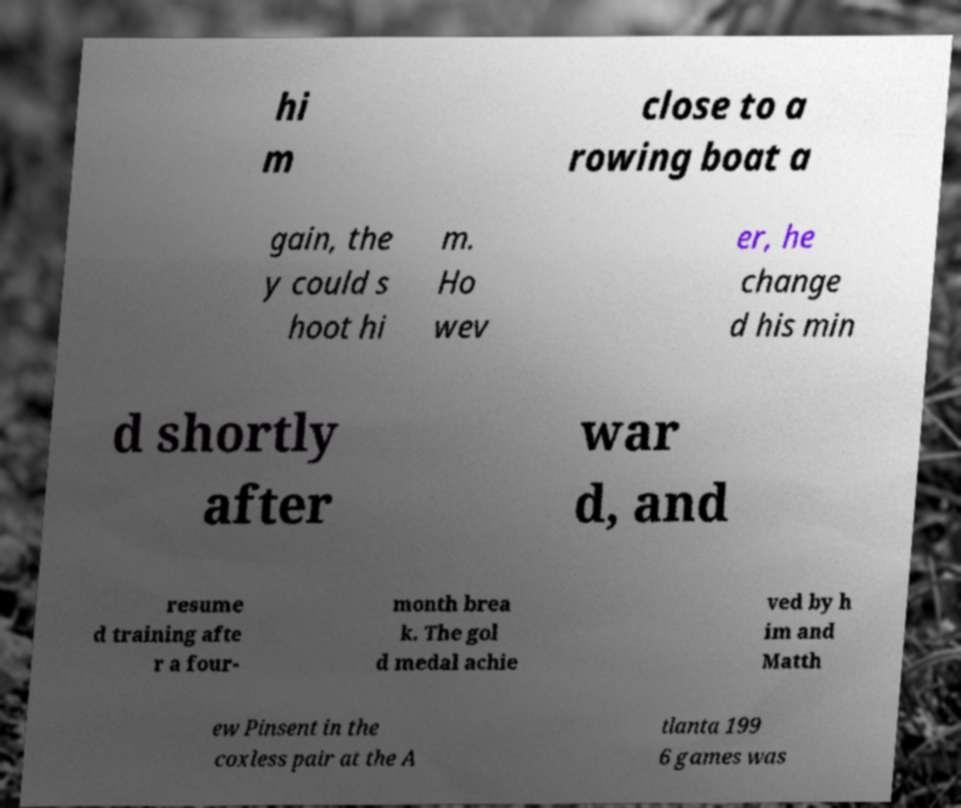Can you read and provide the text displayed in the image?This photo seems to have some interesting text. Can you extract and type it out for me? hi m close to a rowing boat a gain, the y could s hoot hi m. Ho wev er, he change d his min d shortly after war d, and resume d training afte r a four- month brea k. The gol d medal achie ved by h im and Matth ew Pinsent in the coxless pair at the A tlanta 199 6 games was 